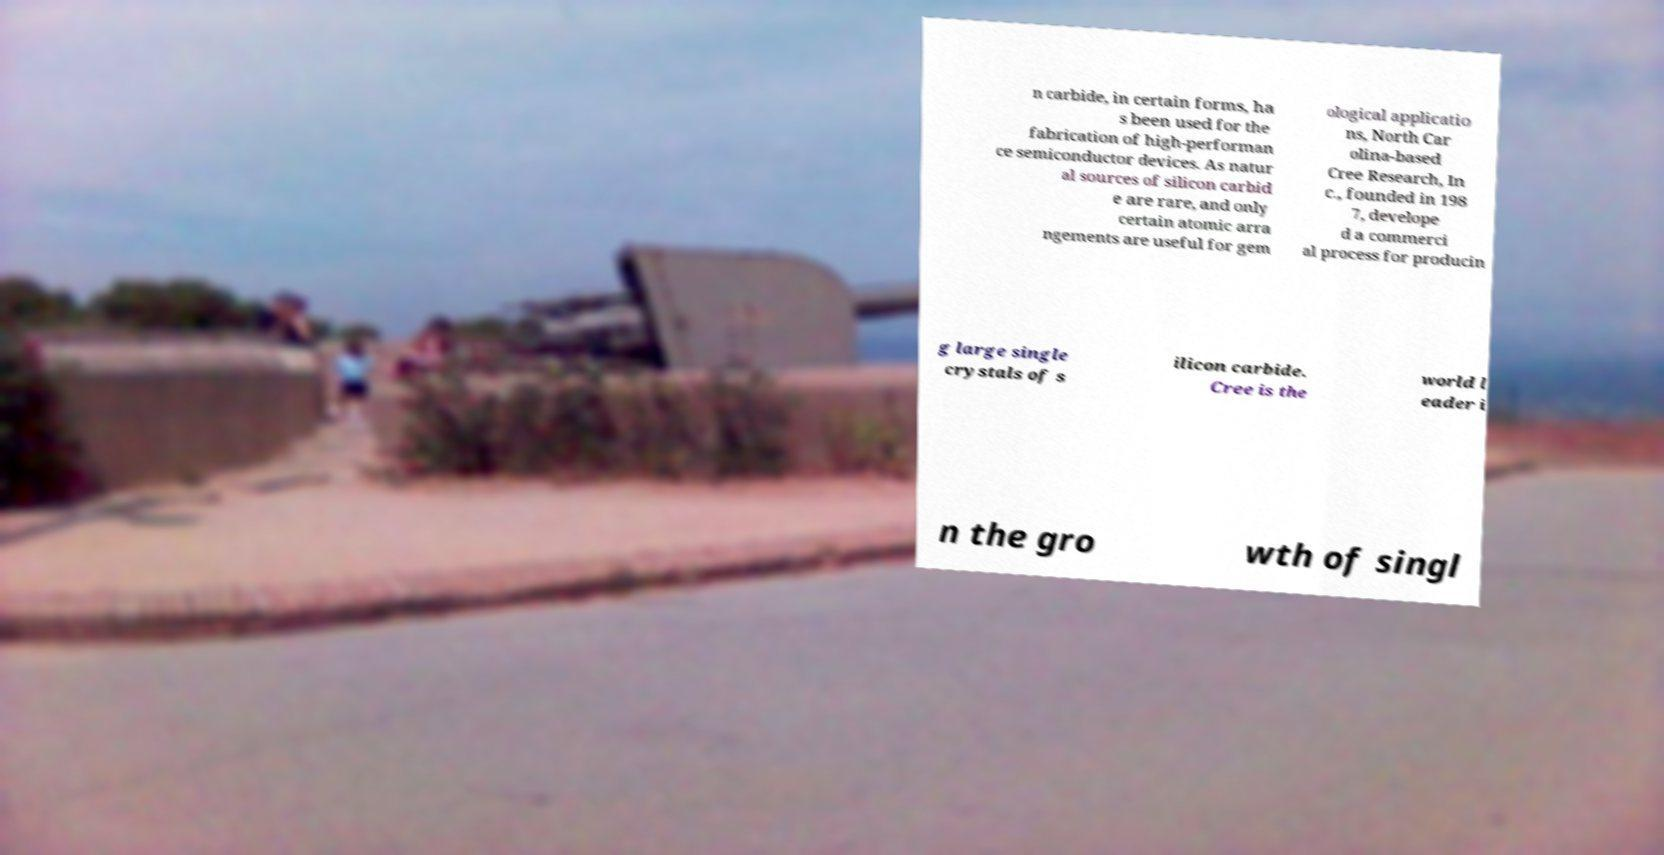Could you extract and type out the text from this image? n carbide, in certain forms, ha s been used for the fabrication of high-performan ce semiconductor devices. As natur al sources of silicon carbid e are rare, and only certain atomic arra ngements are useful for gem ological applicatio ns, North Car olina-based Cree Research, In c., founded in 198 7, develope d a commerci al process for producin g large single crystals of s ilicon carbide. Cree is the world l eader i n the gro wth of singl 